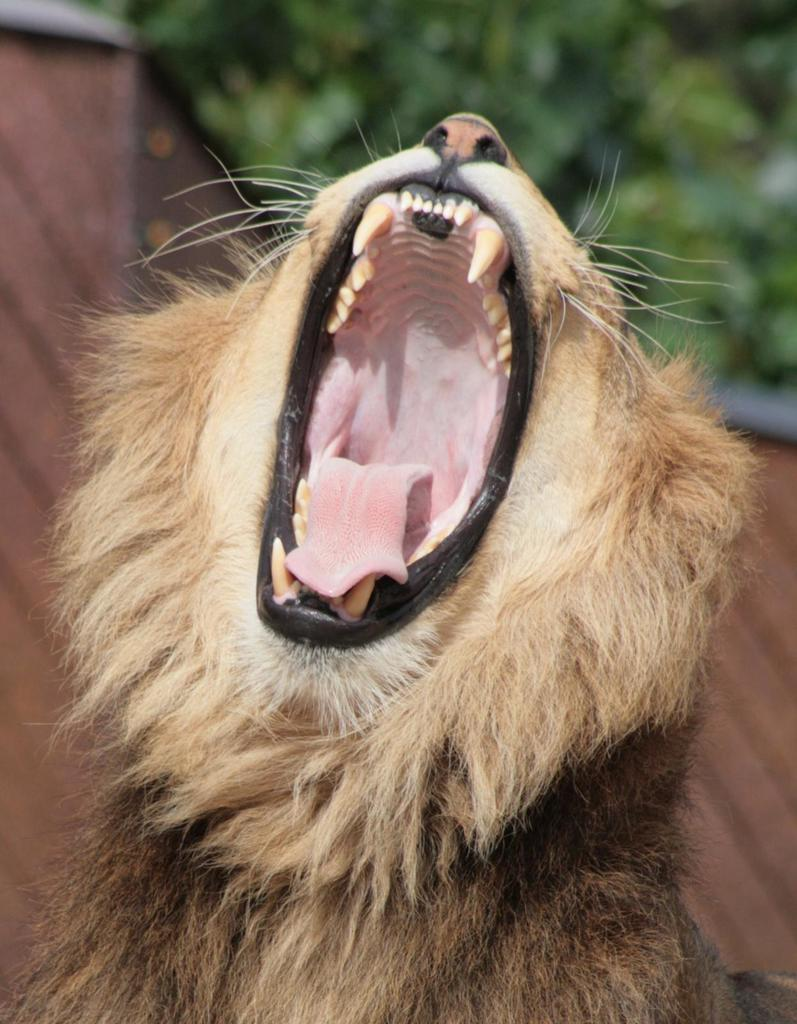What type of animal is in the image? There is a dog in the image. Can you describe the dog's appearance? The dog is pale brown and black in color. What type of surface is visible in the image? There is a wooden surface in the image. How would you describe the background of the image? The background of the image is blurred. What type of band is performing in the image? There is no band present in the image; it features a dog on a wooden surface with a blurred background. 